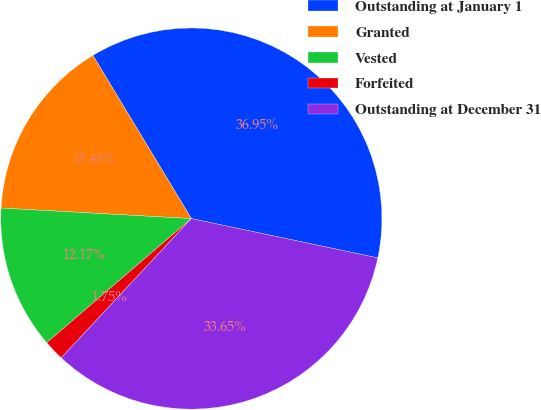Convert chart to OTSL. <chart><loc_0><loc_0><loc_500><loc_500><pie_chart><fcel>Outstanding at January 1<fcel>Granted<fcel>Vested<fcel>Forfeited<fcel>Outstanding at December 31<nl><fcel>36.95%<fcel>15.48%<fcel>12.17%<fcel>1.75%<fcel>33.65%<nl></chart> 